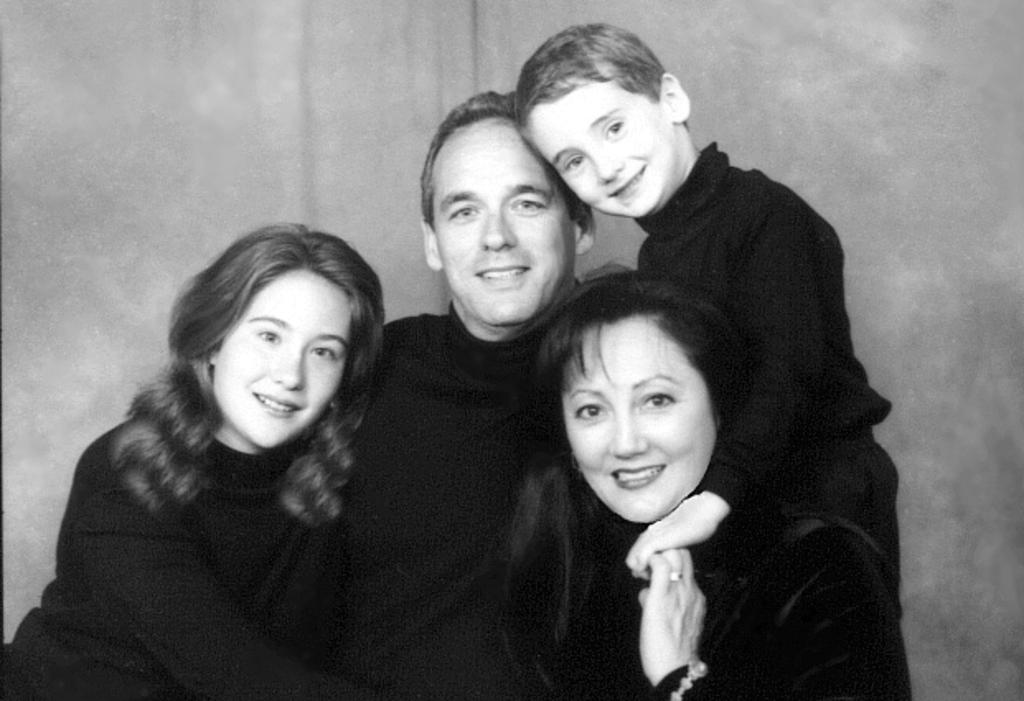How many people are present in the image? There are three people in the image: a man, two women, and a boy. What is the color of the background in the image? The background of the image is grey. What type of stem can be seen growing from the boy's head in the image? There is no stem growing from the boy's head in the image. What type of milk is being served to the man in the image? There is no milk present in the image. 